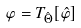Convert formula to latex. <formula><loc_0><loc_0><loc_500><loc_500>\varphi = { T } _ { \hat { \Theta } } [ \hat { \varphi } ]</formula> 